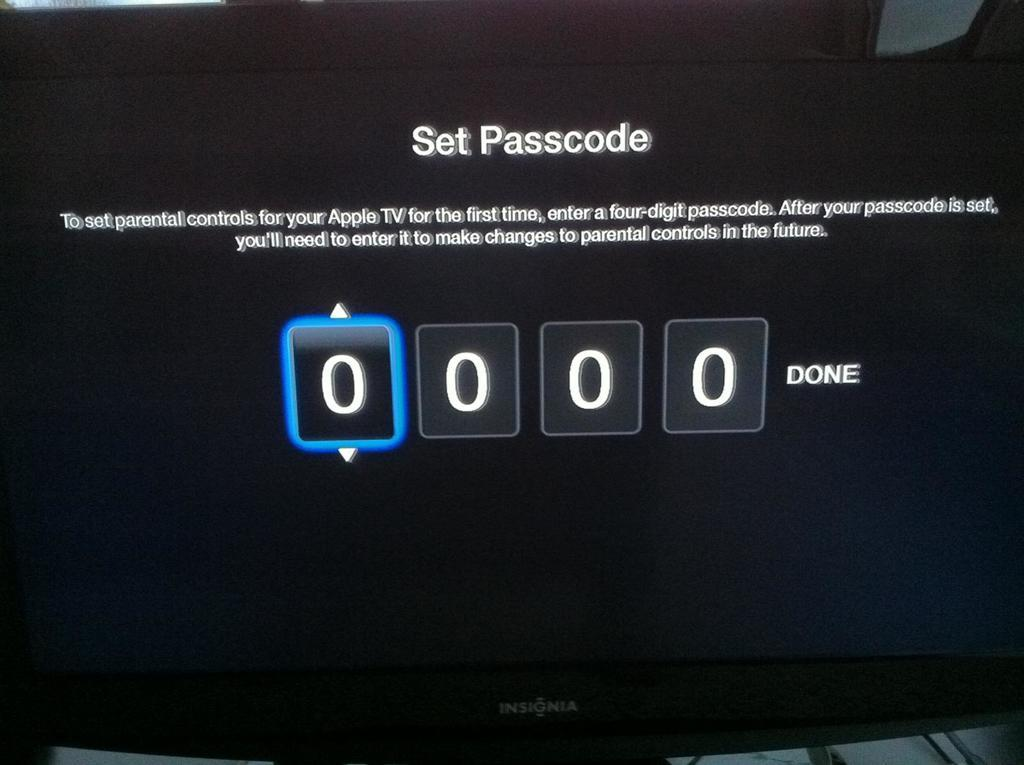<image>
Give a short and clear explanation of the subsequent image. A video screen displaying the instructions on how to set the password up. 